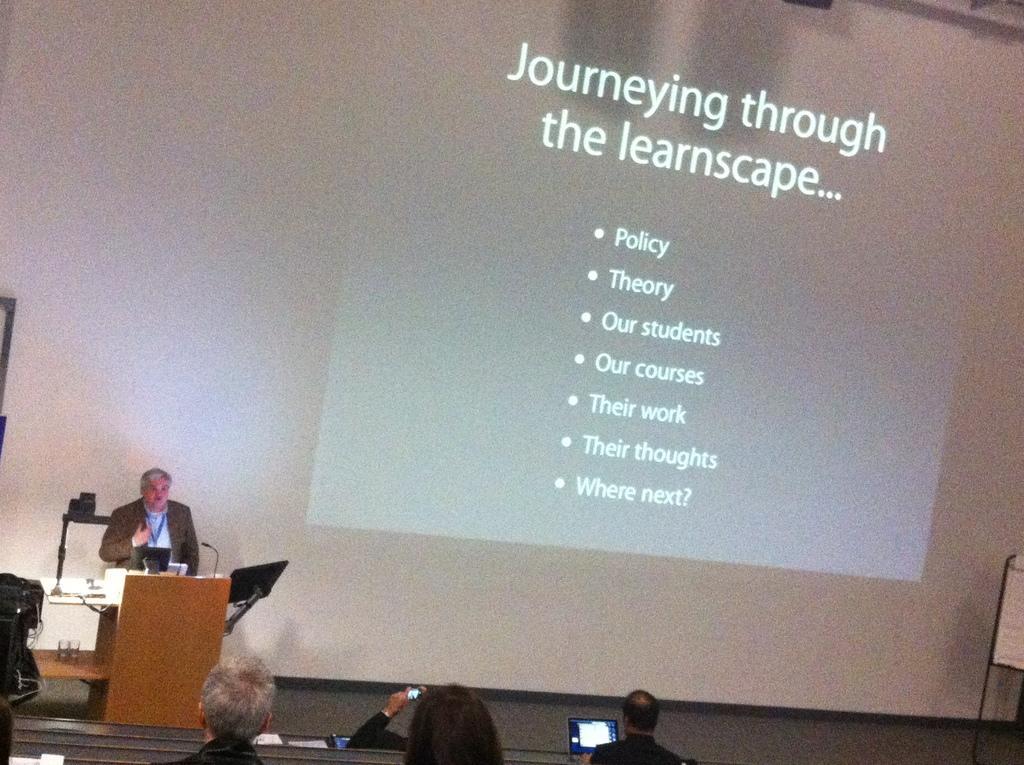Can you describe this image briefly? In the foreground of this image, there is a screen of a projector. On the left side of the image, there is a man near a podium consisting of mic in front of him. On the bottom, there are persons sitting with phones and laptops. 